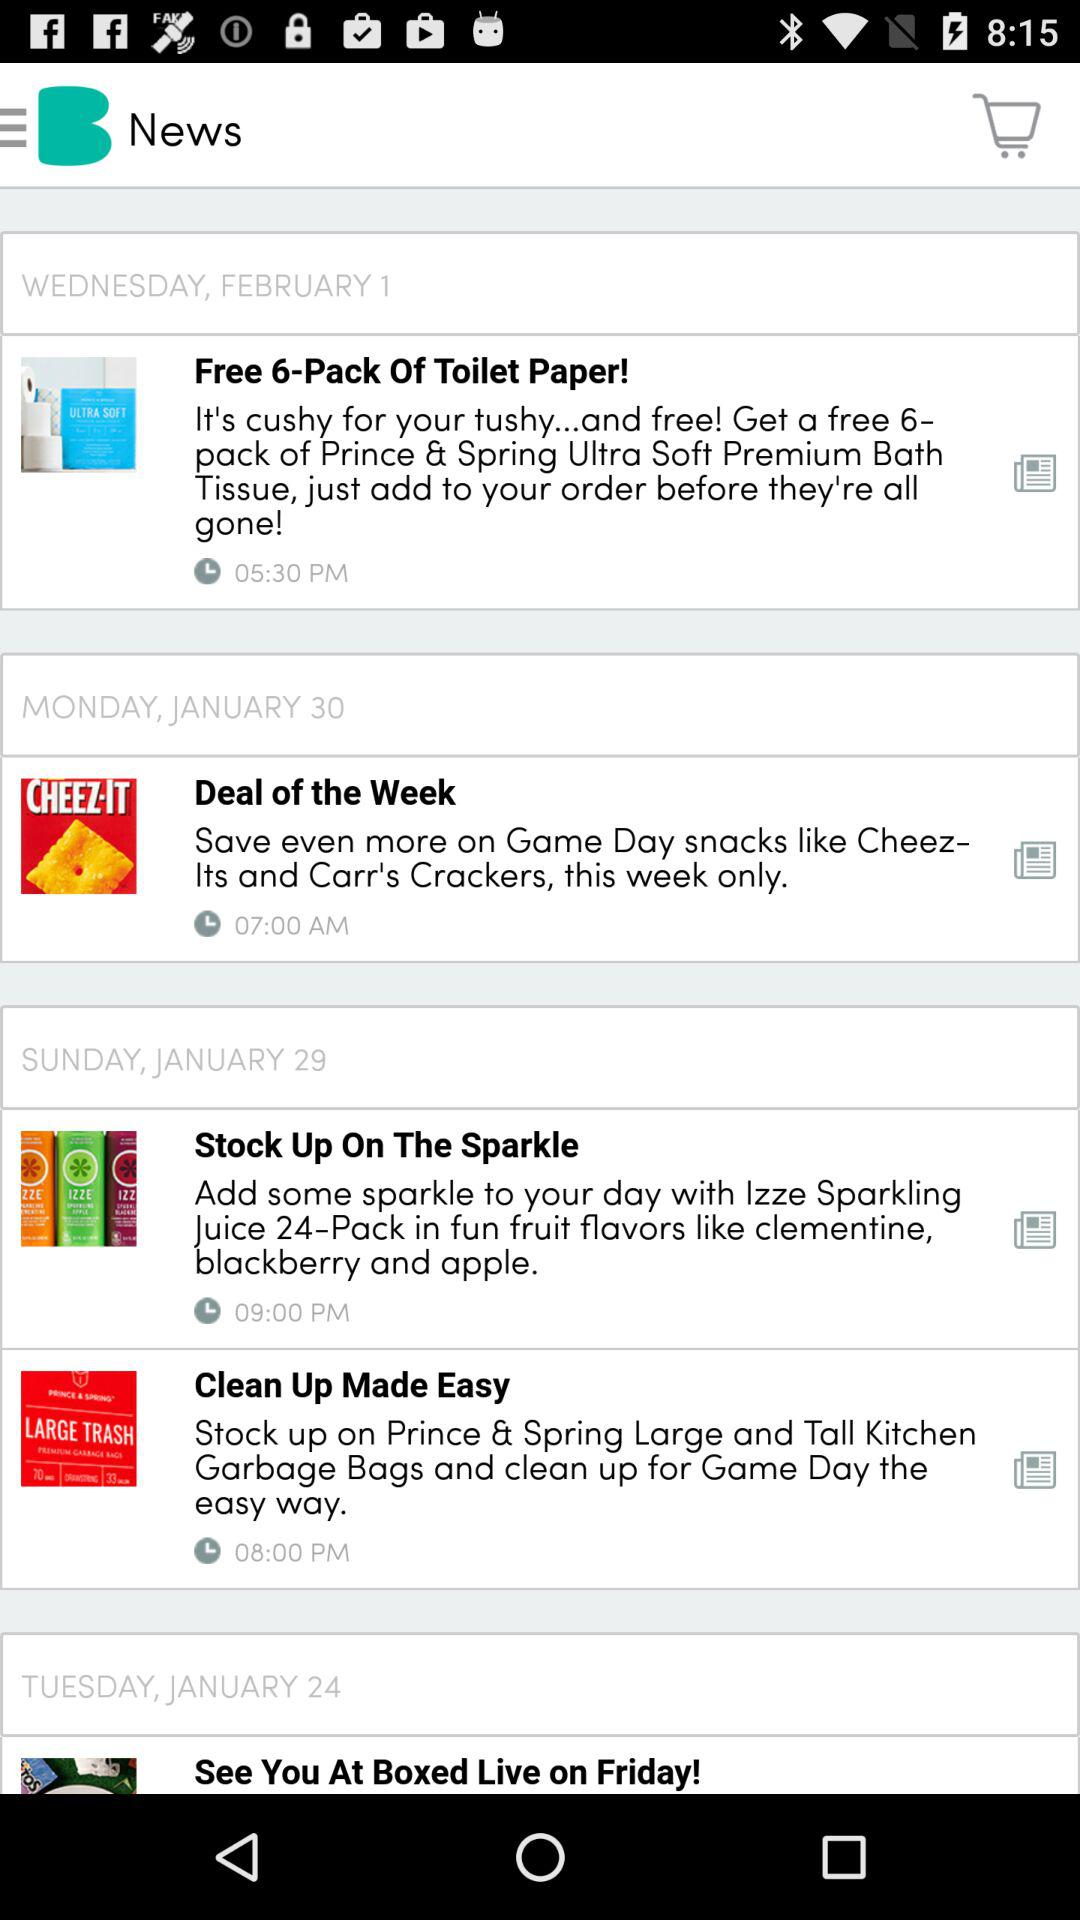What is the date of the news "Free 6-Pack Of Toilet Paper!"? The date is Wednesday, February 1. 